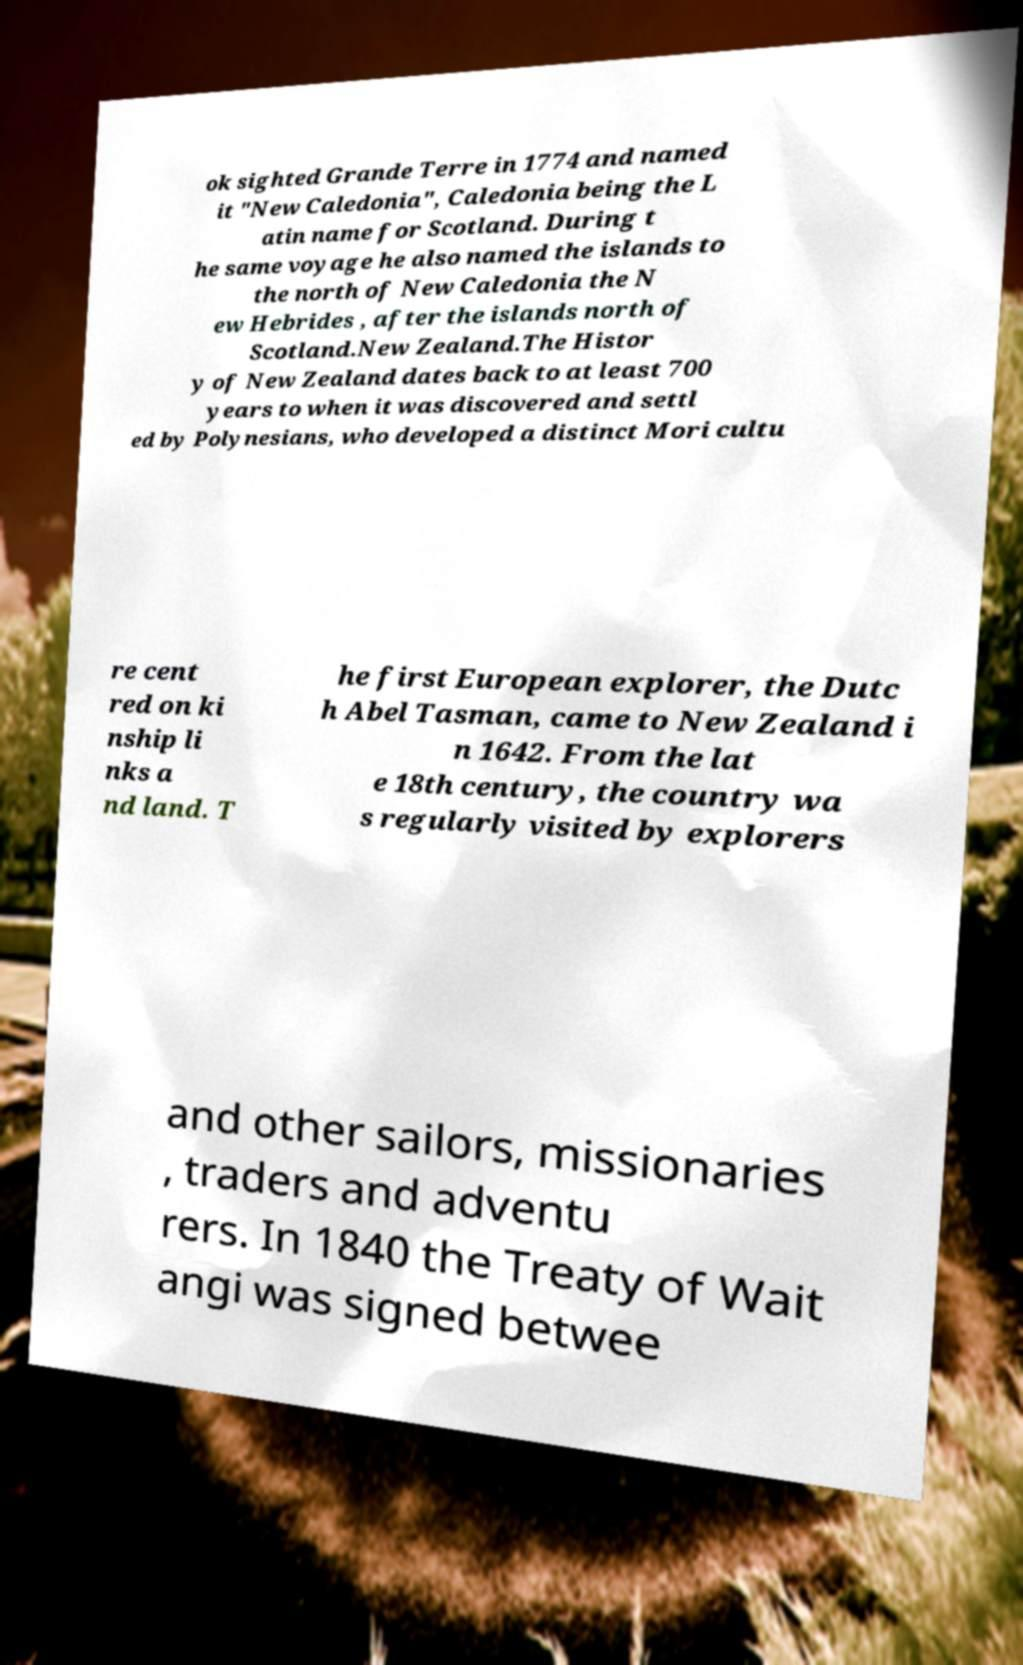Could you extract and type out the text from this image? ok sighted Grande Terre in 1774 and named it "New Caledonia", Caledonia being the L atin name for Scotland. During t he same voyage he also named the islands to the north of New Caledonia the N ew Hebrides , after the islands north of Scotland.New Zealand.The Histor y of New Zealand dates back to at least 700 years to when it was discovered and settl ed by Polynesians, who developed a distinct Mori cultu re cent red on ki nship li nks a nd land. T he first European explorer, the Dutc h Abel Tasman, came to New Zealand i n 1642. From the lat e 18th century, the country wa s regularly visited by explorers and other sailors, missionaries , traders and adventu rers. In 1840 the Treaty of Wait angi was signed betwee 